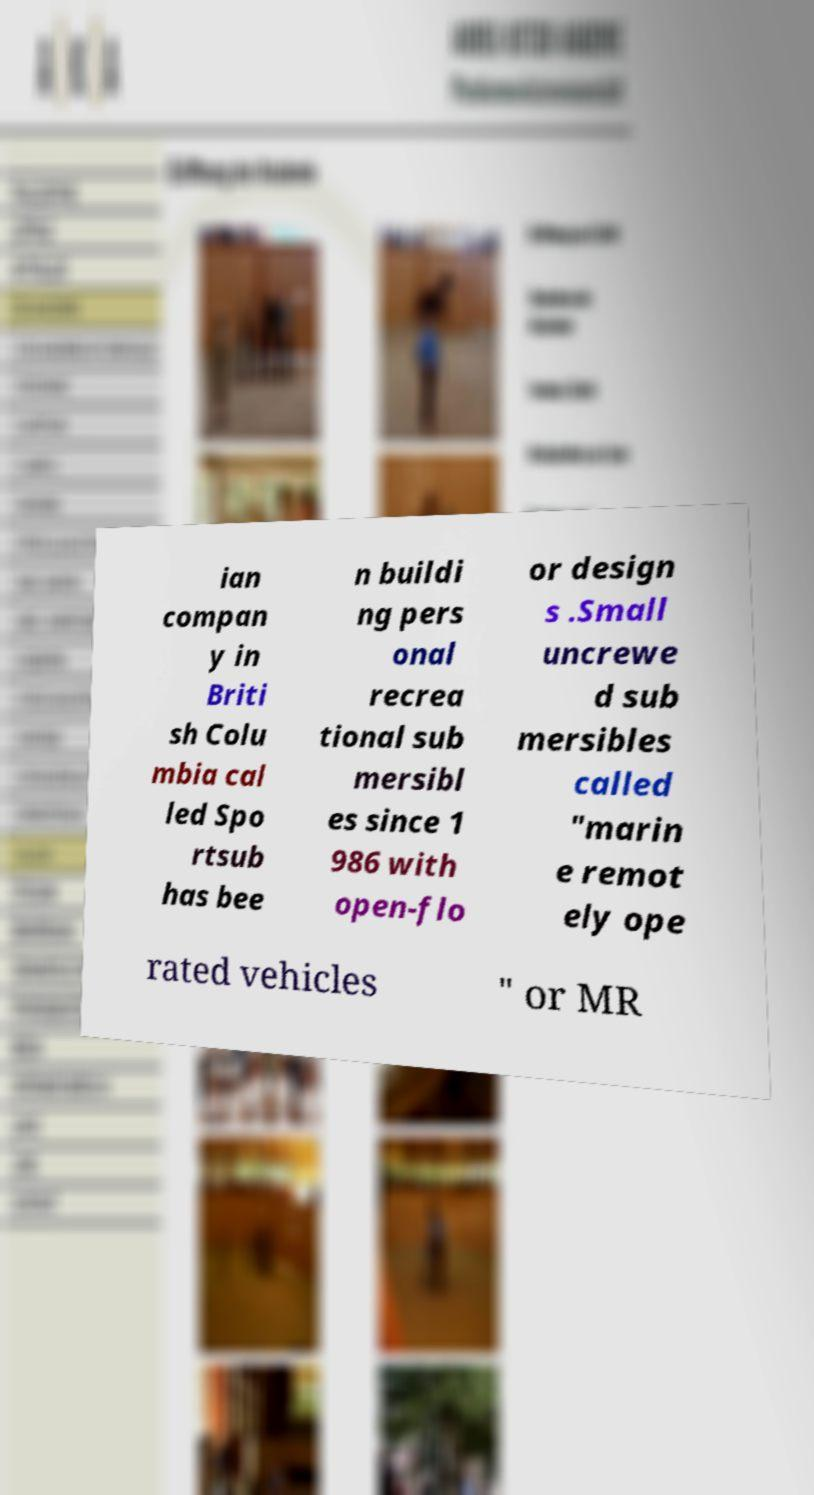Please read and relay the text visible in this image. What does it say? ian compan y in Briti sh Colu mbia cal led Spo rtsub has bee n buildi ng pers onal recrea tional sub mersibl es since 1 986 with open-flo or design s .Small uncrewe d sub mersibles called "marin e remot ely ope rated vehicles " or MR 